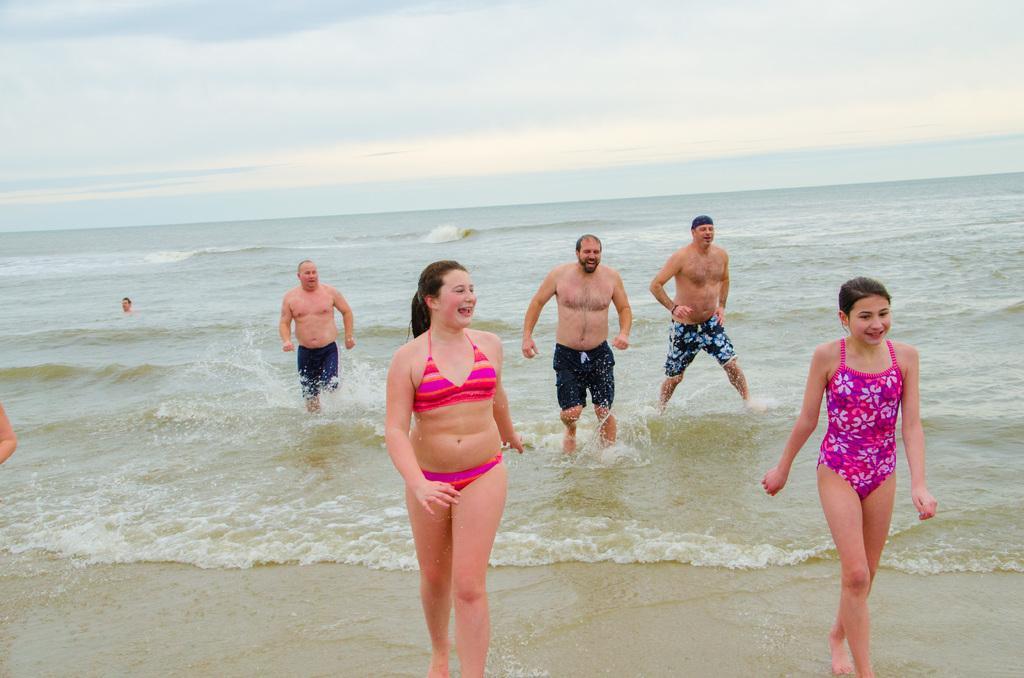How would you summarize this image in a sentence or two? In this picture we can observe women and men in the beach. In the background there is an ocean. We can observe a sky with clouds. All of them were smiling. 